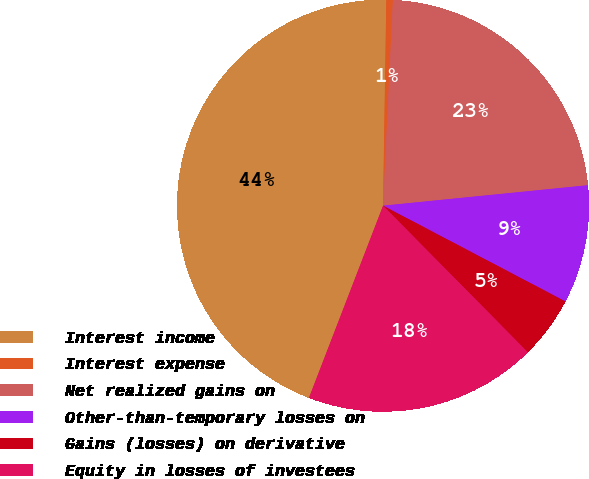Convert chart to OTSL. <chart><loc_0><loc_0><loc_500><loc_500><pie_chart><fcel>Interest income<fcel>Interest expense<fcel>Net realized gains on<fcel>Other-than-temporary losses on<fcel>Gains (losses) on derivative<fcel>Equity in losses of investees<nl><fcel>44.39%<fcel>0.51%<fcel>22.65%<fcel>9.28%<fcel>4.9%<fcel>18.26%<nl></chart> 